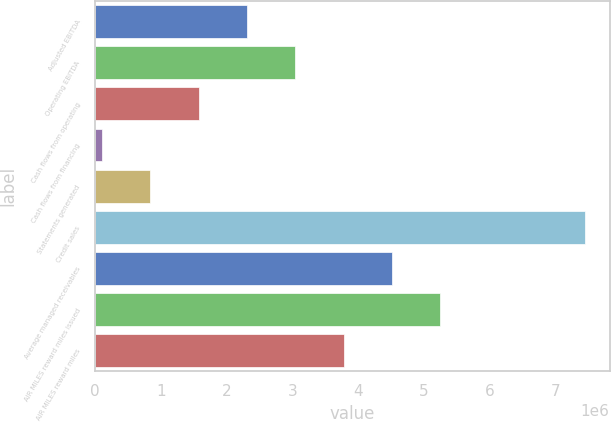Convert chart. <chart><loc_0><loc_0><loc_500><loc_500><bar_chart><fcel>Adjusted EBITDA<fcel>Operating EBITDA<fcel>Cash flows from operating<fcel>Cash flows from financing<fcel>Statements generated<fcel>Credit sales<fcel>Average managed receivables<fcel>AIR MILES reward miles issued<fcel>AIR MILES reward miles<nl><fcel>2.31188e+06<fcel>3.04508e+06<fcel>1.57868e+06<fcel>112270<fcel>845473<fcel>7.4443e+06<fcel>4.51149e+06<fcel>5.24469e+06<fcel>3.77828e+06<nl></chart> 